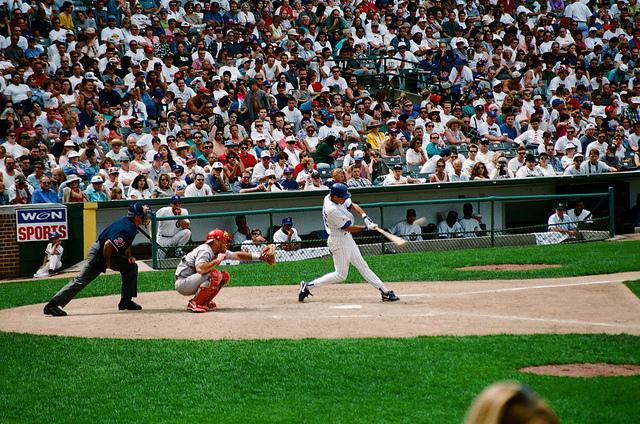Are all the seats occupied?
Concise answer only. Yes. What color shirts are most of the people wearing?
Answer briefly. White. What sport are they playing?
Give a very brief answer. Baseball. What network is broadcasting the game?
Write a very short answer. Wgn. 